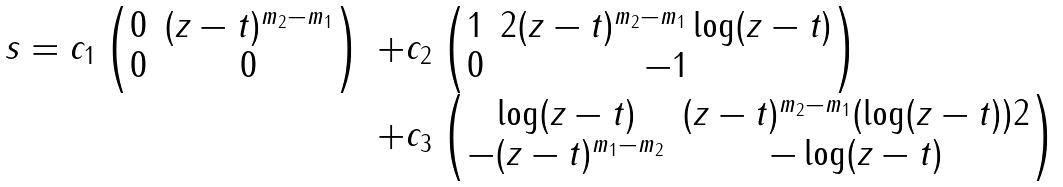<formula> <loc_0><loc_0><loc_500><loc_500>\begin{array} { l l } s = c _ { 1 } \begin{pmatrix} 0 & ( z - t ) ^ { m _ { 2 } - m _ { 1 } } \\ 0 & 0 \end{pmatrix} & + c _ { 2 } \begin{pmatrix} 1 & 2 ( z - t ) ^ { m _ { 2 } - m _ { 1 } } \log ( z - t ) \\ 0 & - 1 \end{pmatrix} \\ \quad & + c _ { 3 } \begin{pmatrix} \log ( z - t ) & ( z - t ) ^ { m _ { 2 } - m _ { 1 } } ( \log ( z - t ) ) 2 \\ - ( z - t ) ^ { m _ { 1 } - m _ { 2 } } & - \log ( z - t ) \end{pmatrix} \end{array}</formula> 